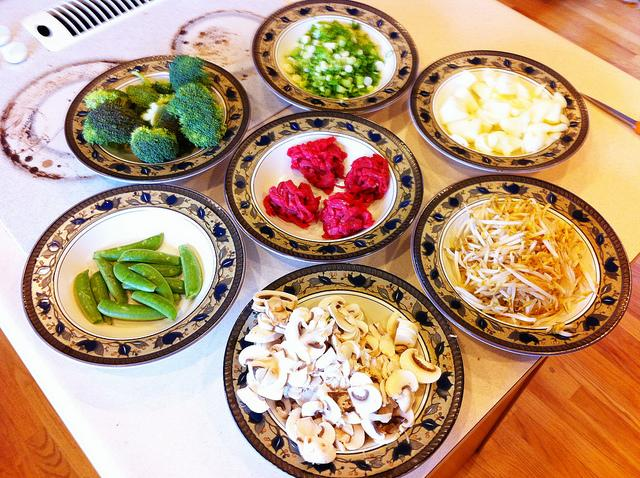How many plates are on the table? Please explain your reasoning. seven. The plate in the center is surrounded by six other plates. 